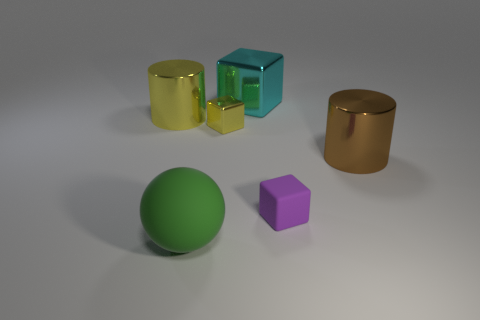Add 3 purple rubber objects. How many objects exist? 9 Subtract all balls. How many objects are left? 5 Add 5 yellow things. How many yellow things exist? 7 Subtract 0 gray cubes. How many objects are left? 6 Subtract all large red matte objects. Subtract all brown cylinders. How many objects are left? 5 Add 1 rubber things. How many rubber things are left? 3 